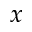Convert formula to latex. <formula><loc_0><loc_0><loc_500><loc_500>x</formula> 